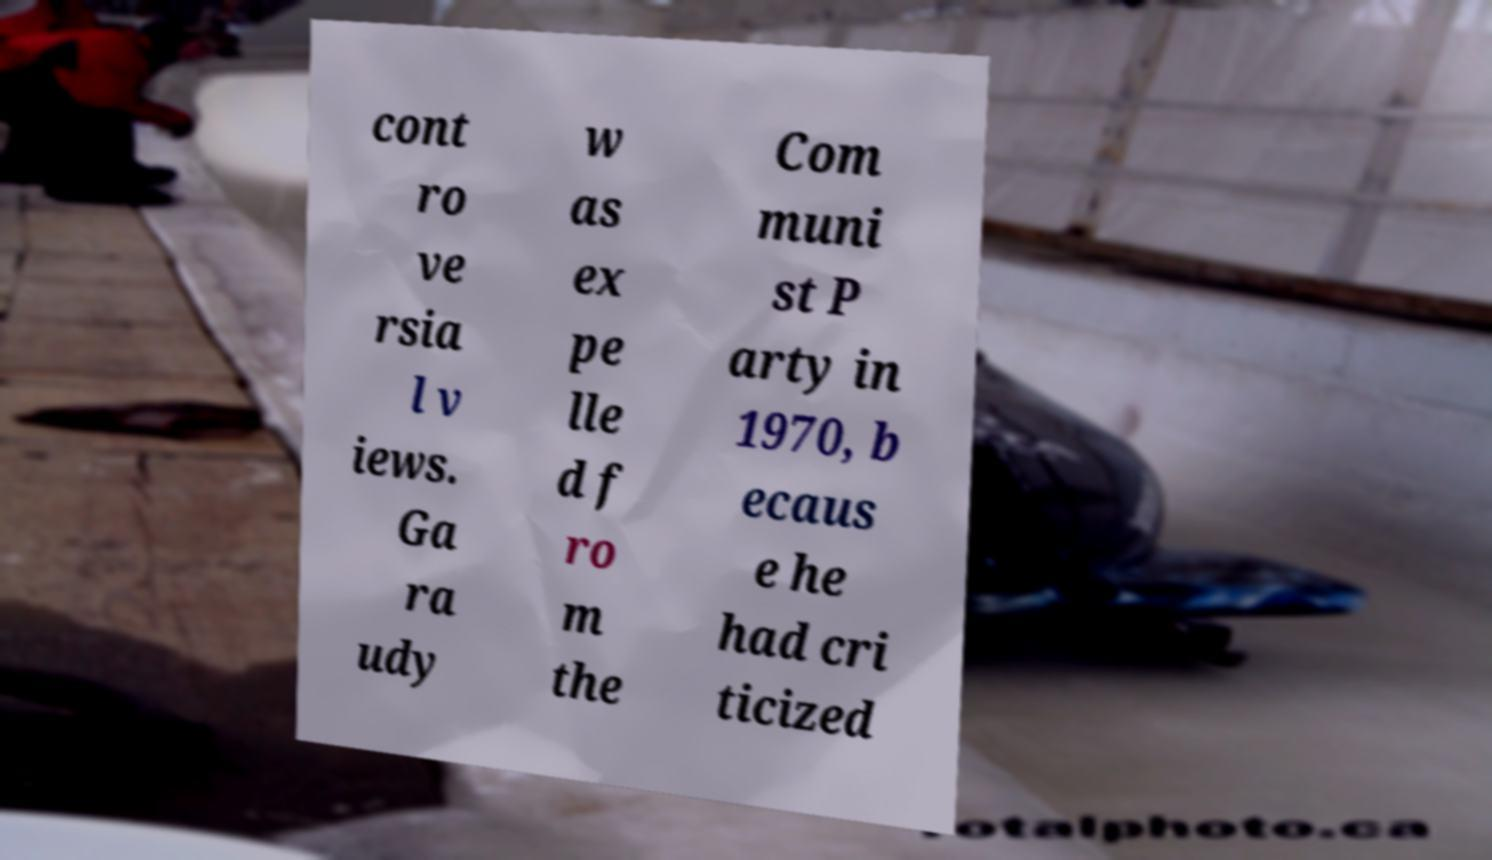Please identify and transcribe the text found in this image. cont ro ve rsia l v iews. Ga ra udy w as ex pe lle d f ro m the Com muni st P arty in 1970, b ecaus e he had cri ticized 